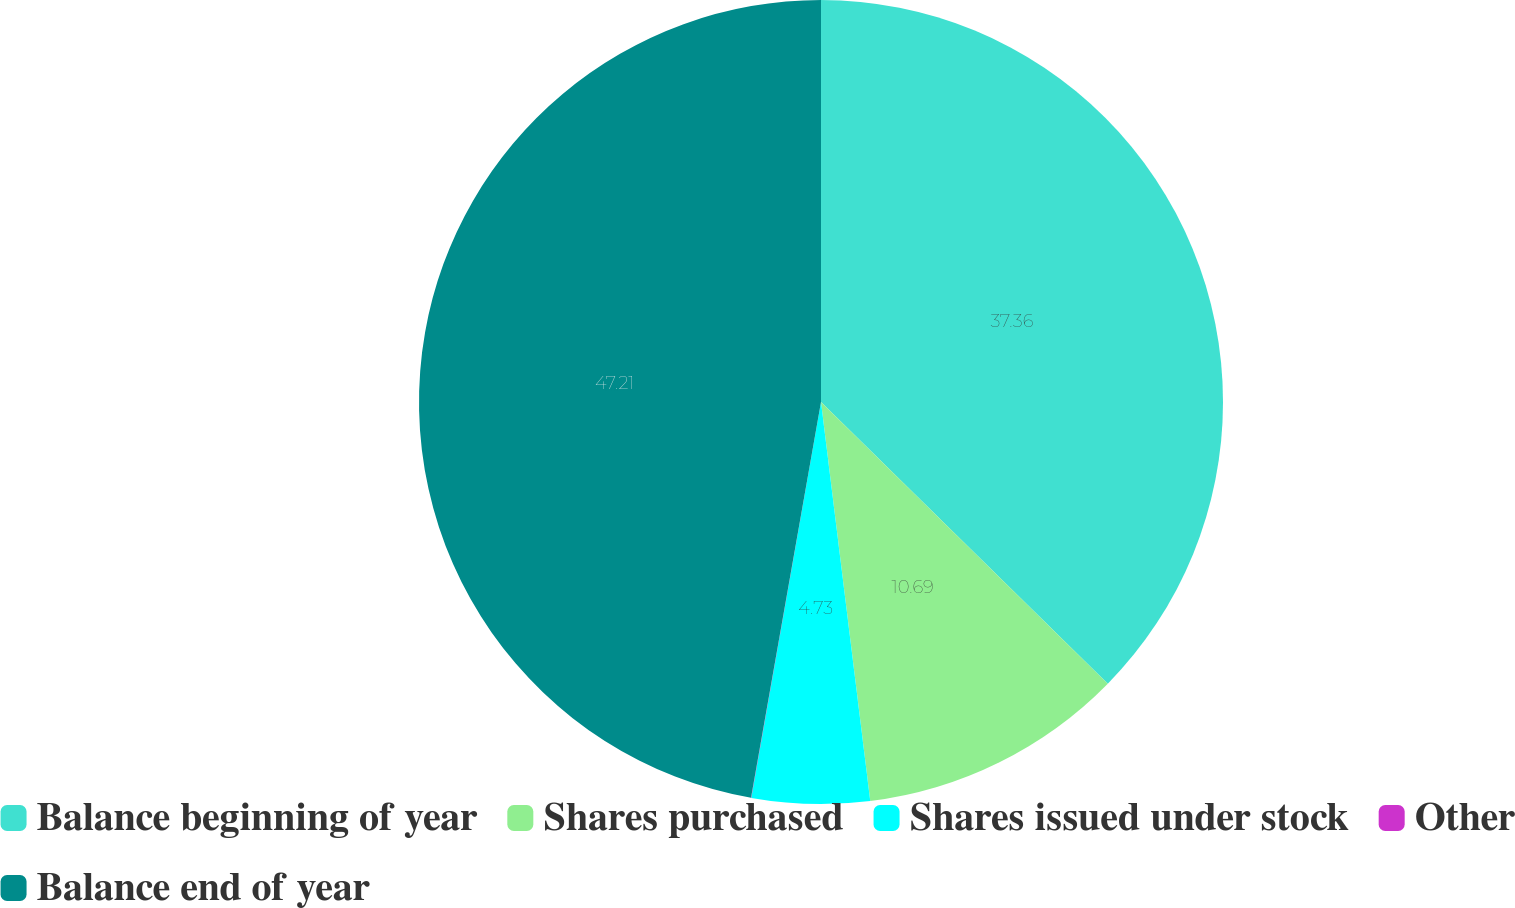<chart> <loc_0><loc_0><loc_500><loc_500><pie_chart><fcel>Balance beginning of year<fcel>Shares purchased<fcel>Shares issued under stock<fcel>Other<fcel>Balance end of year<nl><fcel>37.36%<fcel>10.69%<fcel>4.73%<fcel>0.01%<fcel>47.22%<nl></chart> 